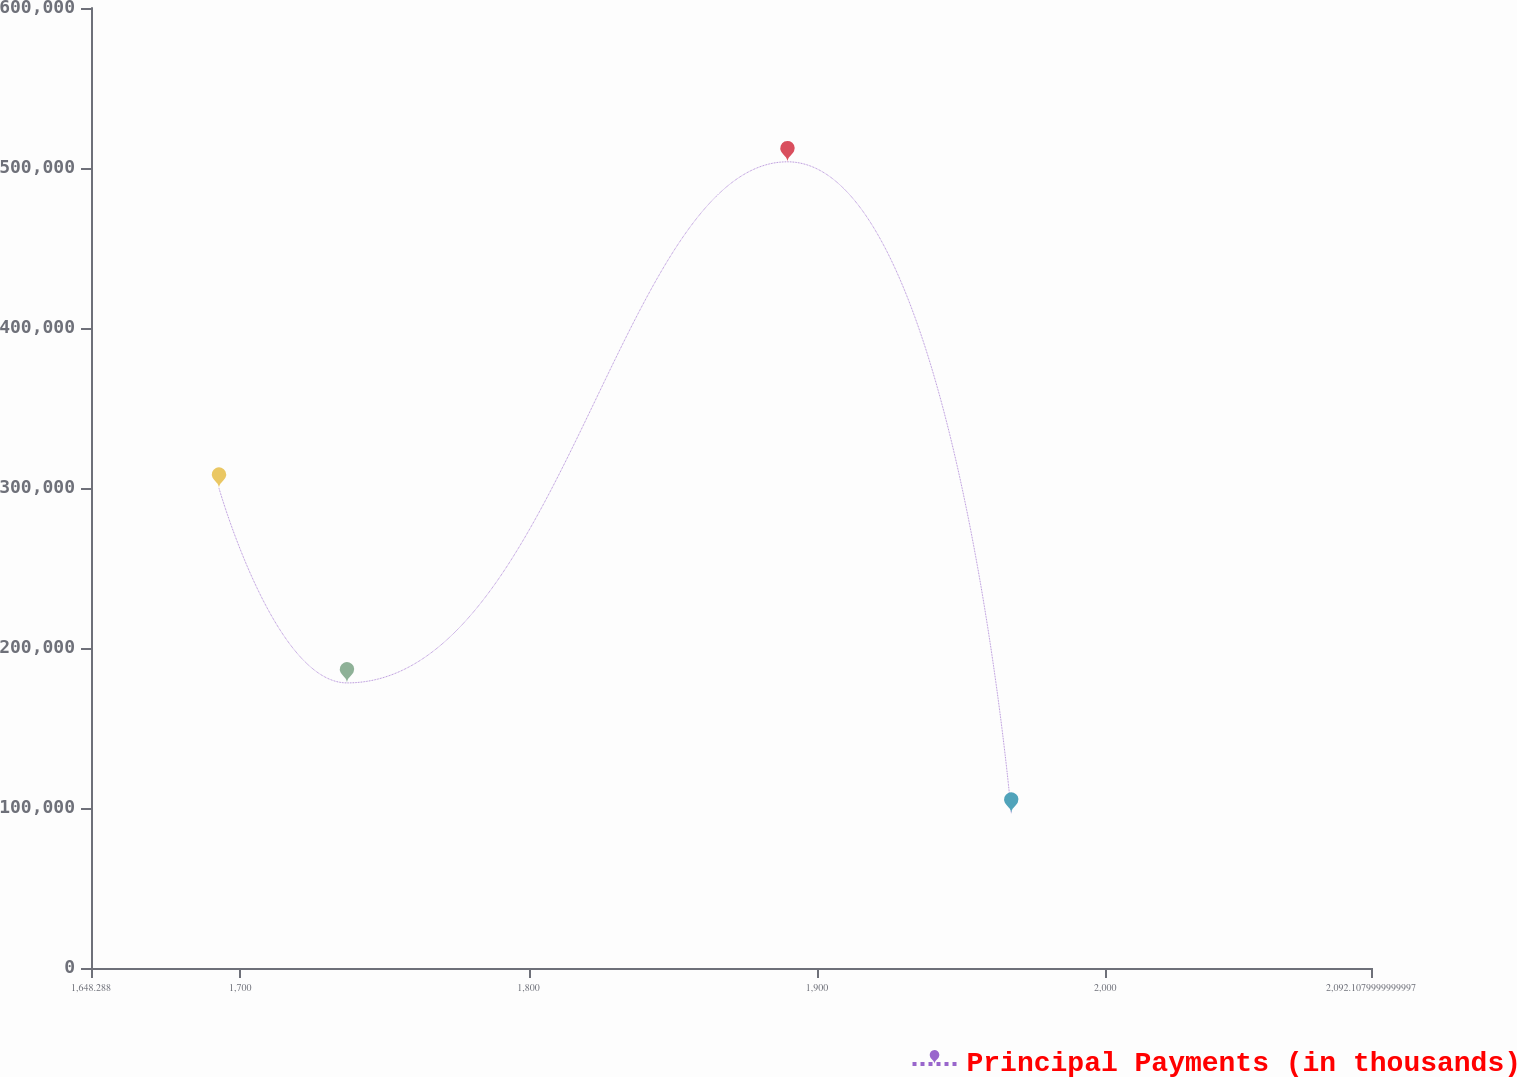<chart> <loc_0><loc_0><loc_500><loc_500><line_chart><ecel><fcel>Principal Payments (in thousands)<nl><fcel>1692.67<fcel>299867<nl><fcel>1737.05<fcel>178186<nl><fcel>1889.79<fcel>503867<nl><fcel>1967.38<fcel>96766<nl><fcel>2136.49<fcel>137476<nl></chart> 